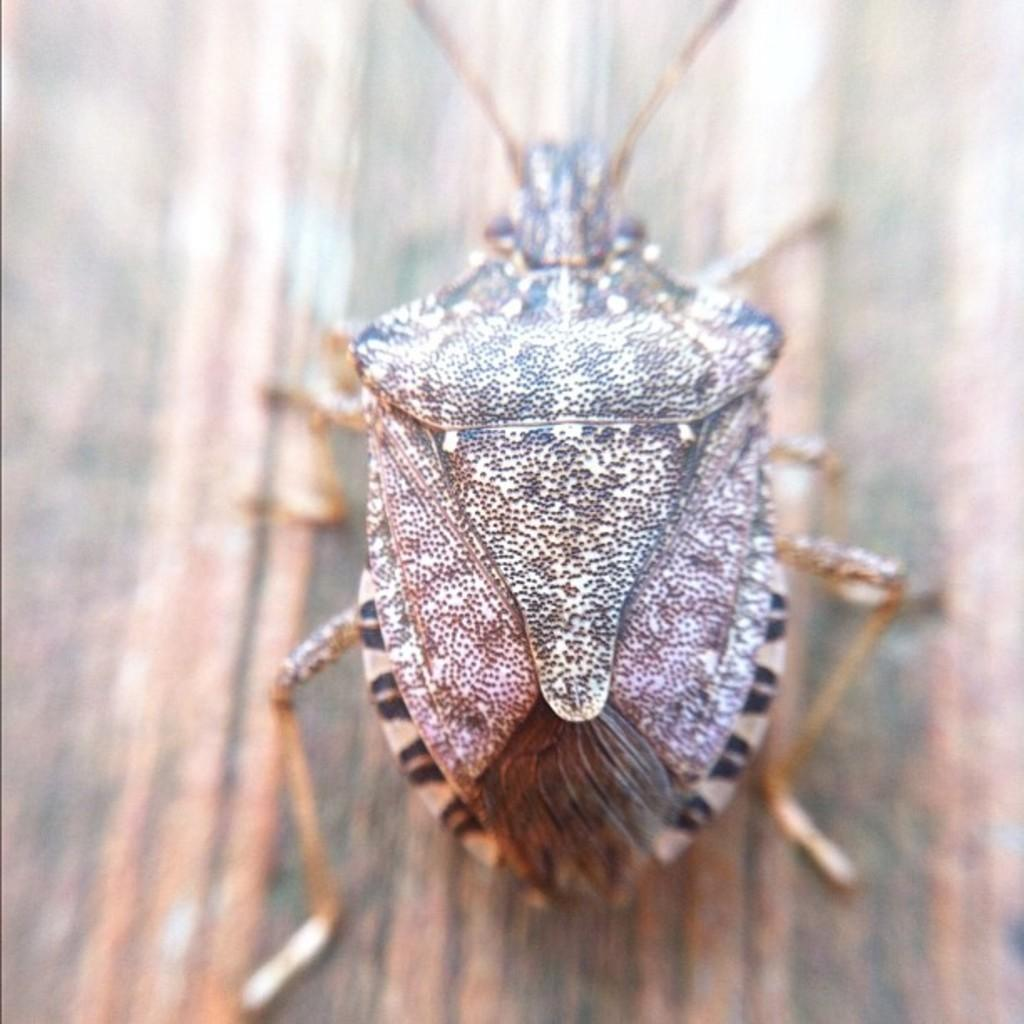What is the main object in the center of the image? There is a piece of wood in the center of the image. What is on the piece of wood? There is an insect on the wood. Can you describe the appearance of the insect? The insect has a cream and black color. How many clocks are hanging on the wall behind the piece of wood? There are no clocks visible in the image; it only features a piece of wood with an insect on it. 